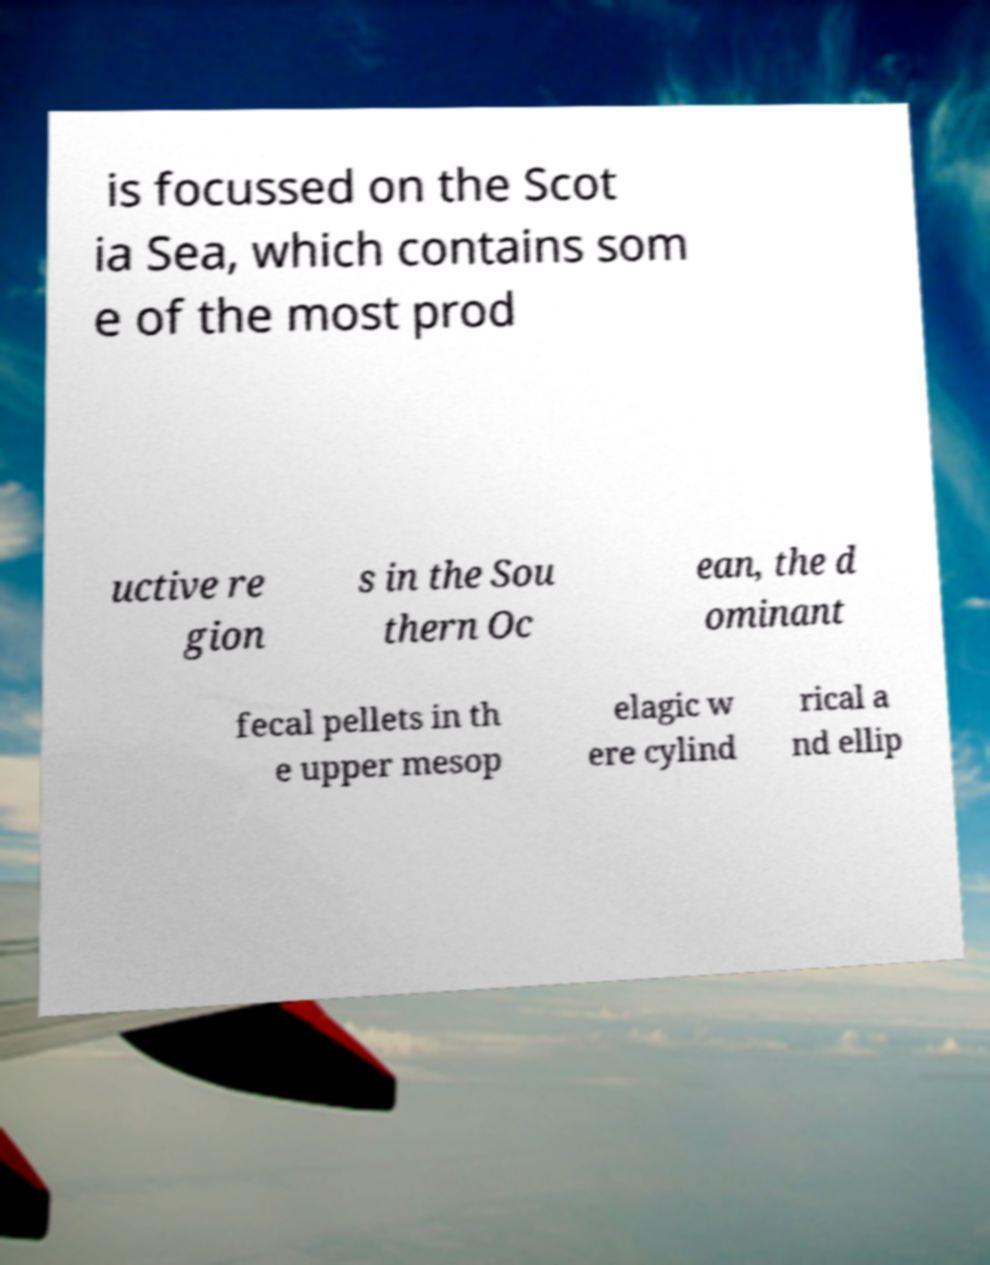Could you assist in decoding the text presented in this image and type it out clearly? is focussed on the Scot ia Sea, which contains som e of the most prod uctive re gion s in the Sou thern Oc ean, the d ominant fecal pellets in th e upper mesop elagic w ere cylind rical a nd ellip 